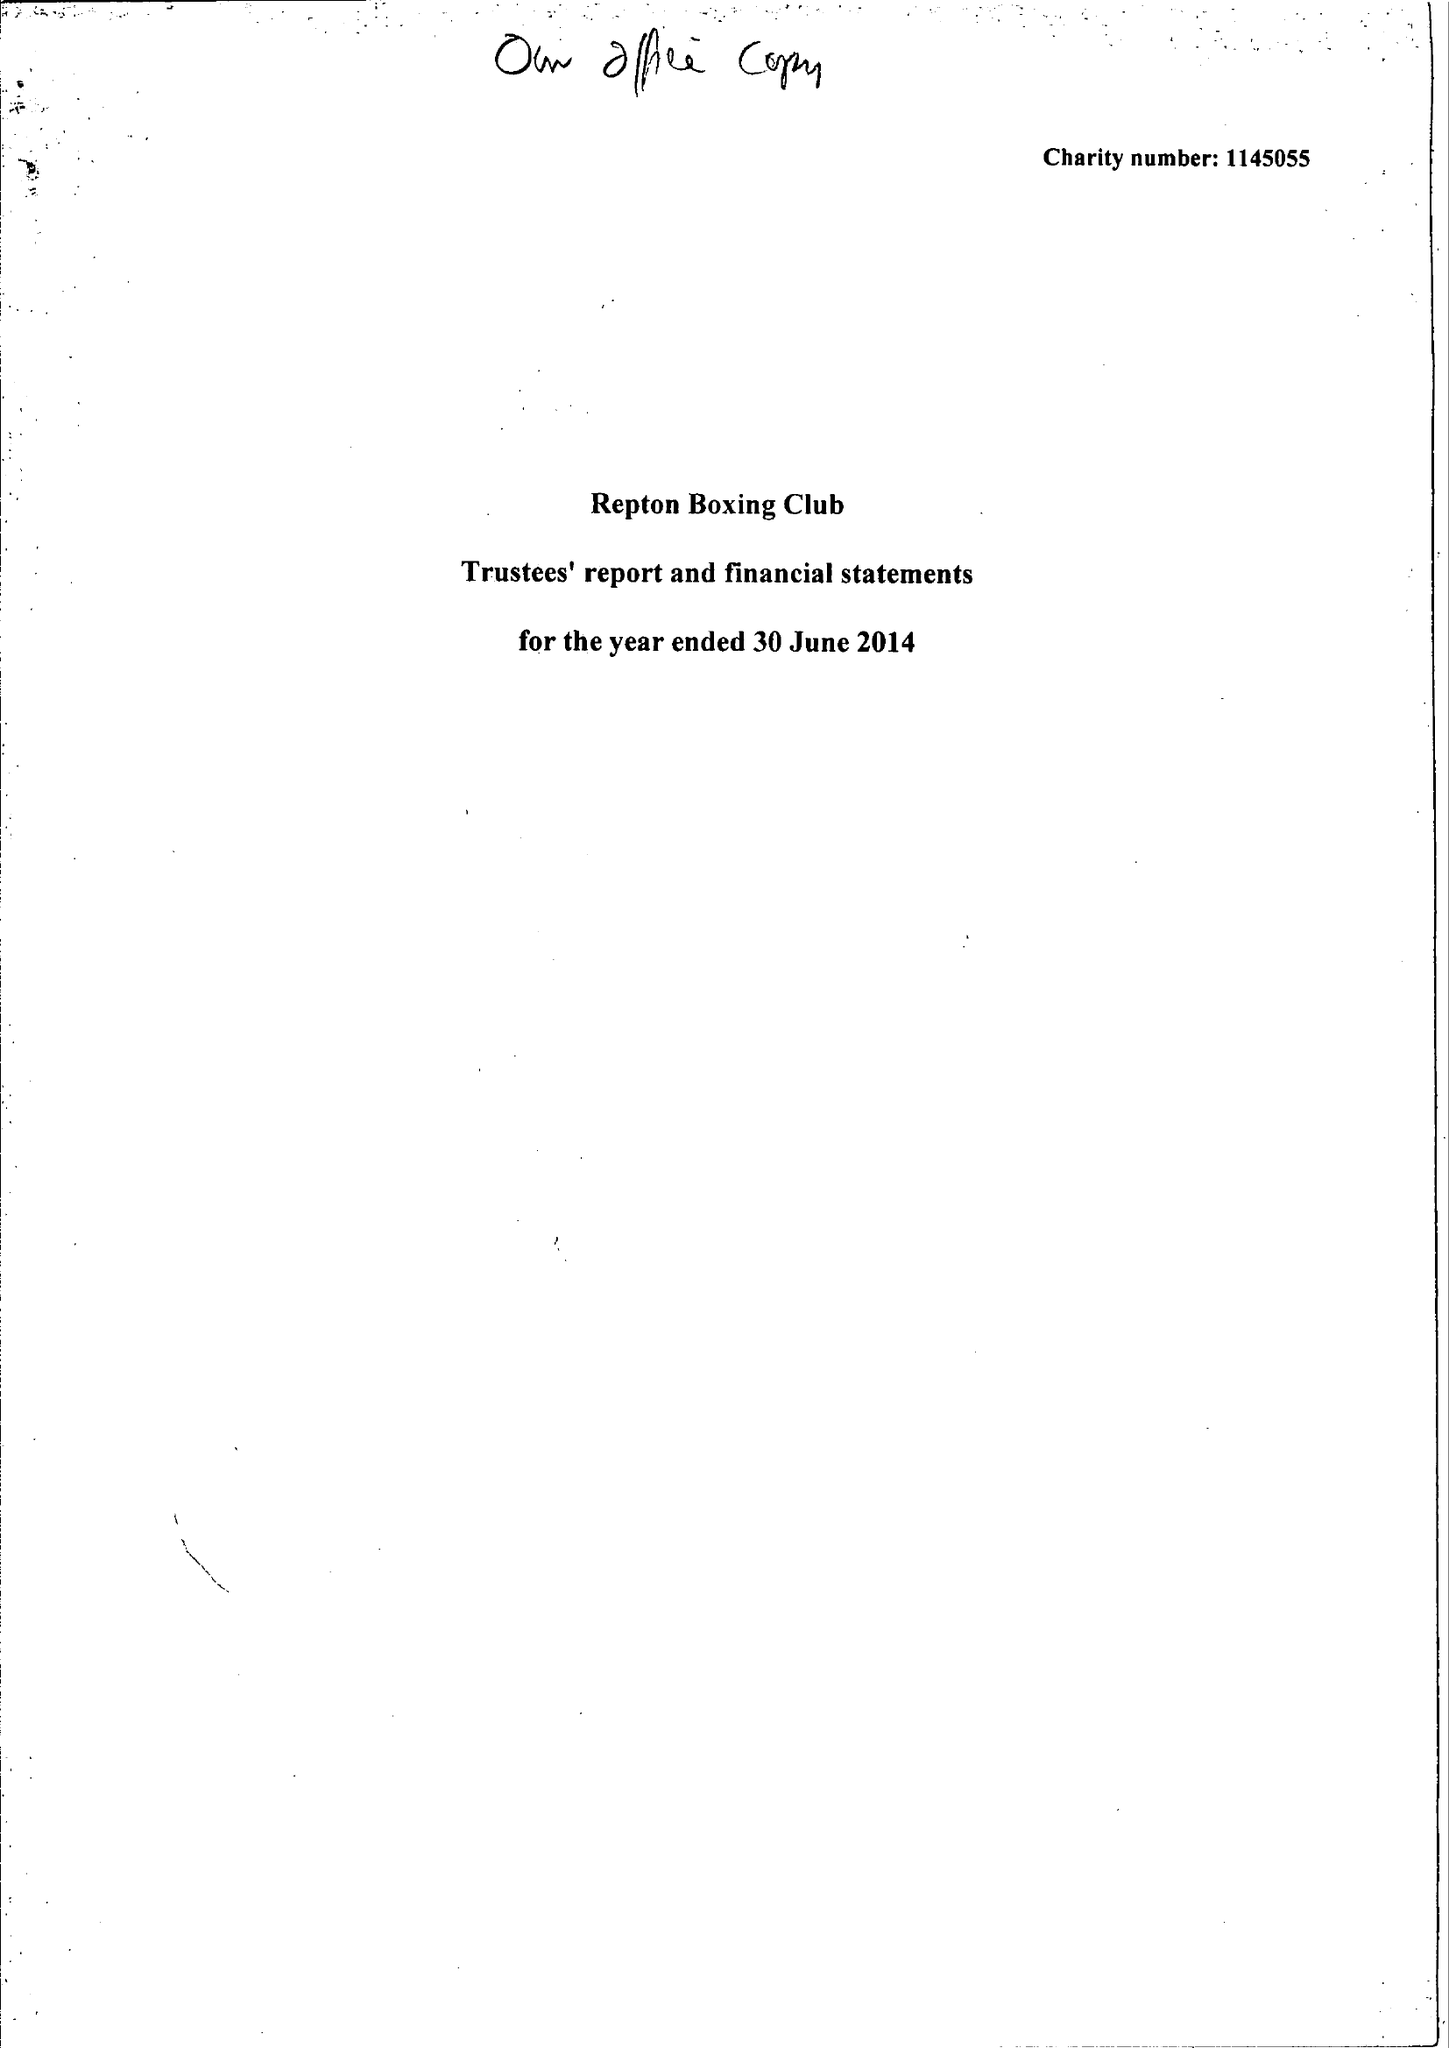What is the value for the address__post_town?
Answer the question using a single word or phrase. LONDON 